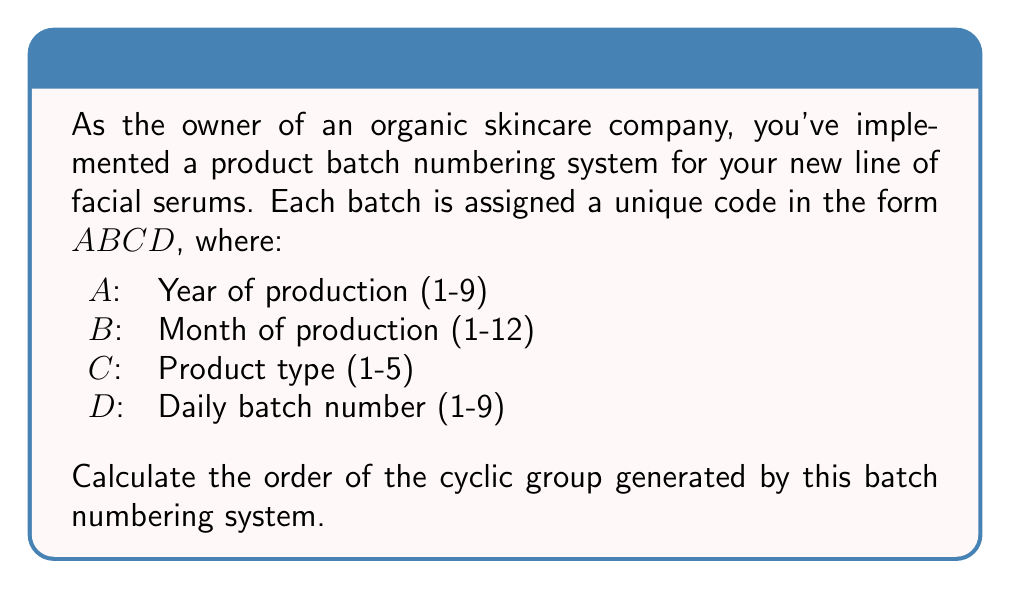Provide a solution to this math problem. Let's approach this step-by-step:

1) First, we need to determine the total number of possible batch codes. This is done by multiplying the number of possibilities for each position:

   $9 \times 12 \times 5 \times 9 = 4860$

2) The order of a cyclic group is equal to the number of elements in the group. In this case, it's the total number of unique batch codes.

3) However, we need to consider if all these combinations are valid. In this system:
   - Year (A) ranges from 1 to 9
   - Month (B) ranges from 1 to 12
   - Product type (C) ranges from 1 to 5
   - Daily batch number (D) ranges from 1 to 9

   All of these are valid integers within their ranges, so all 4860 combinations are possible.

4) In group theory, a cyclic group $\langle g \rangle$ generated by an element $g$ is isomorphic to $\mathbb{Z}/n\mathbb{Z}$, where $n$ is the order of $g$.

5) Therefore, the cyclic group generated by this batch numbering system is isomorphic to $\mathbb{Z}/4860\mathbb{Z}$.

6) The order of this cyclic group is 4860.
Answer: 4860 